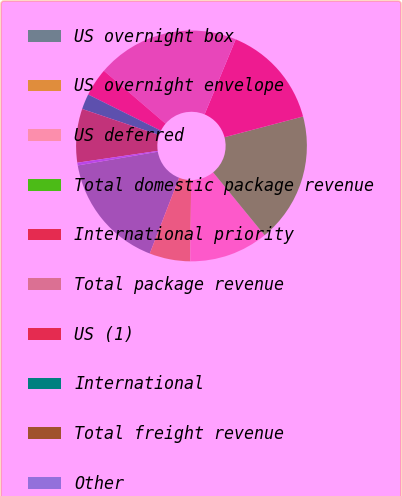<chart> <loc_0><loc_0><loc_500><loc_500><pie_chart><fcel>US overnight box<fcel>US overnight envelope<fcel>US deferred<fcel>Total domestic package revenue<fcel>International priority<fcel>Total package revenue<fcel>US (1)<fcel>International<fcel>Total freight revenue<fcel>Other<nl><fcel>16.41%<fcel>5.73%<fcel>11.07%<fcel>18.19%<fcel>14.63%<fcel>19.97%<fcel>3.94%<fcel>2.16%<fcel>7.51%<fcel>0.38%<nl></chart> 